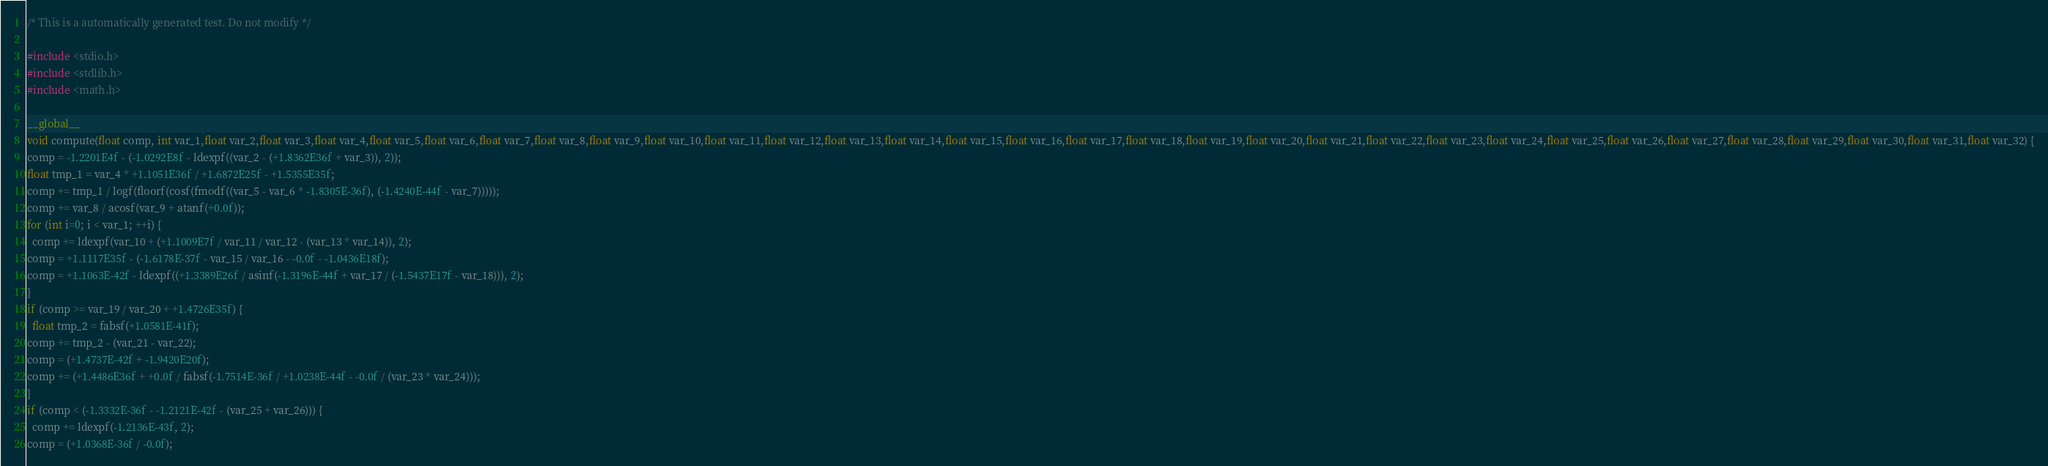<code> <loc_0><loc_0><loc_500><loc_500><_Cuda_>
/* This is a automatically generated test. Do not modify */

#include <stdio.h>
#include <stdlib.h>
#include <math.h>

__global__
void compute(float comp, int var_1,float var_2,float var_3,float var_4,float var_5,float var_6,float var_7,float var_8,float var_9,float var_10,float var_11,float var_12,float var_13,float var_14,float var_15,float var_16,float var_17,float var_18,float var_19,float var_20,float var_21,float var_22,float var_23,float var_24,float var_25,float var_26,float var_27,float var_28,float var_29,float var_30,float var_31,float var_32) {
comp = -1.2201E4f - (-1.0292E8f - ldexpf((var_2 - (+1.8362E36f + var_3)), 2));
float tmp_1 = var_4 * +1.1051E36f / +1.6872E25f - +1.5355E35f;
comp += tmp_1 / logf(floorf(cosf(fmodf((var_5 - var_6 * -1.8305E-36f), (-1.4240E-44f - var_7)))));
comp += var_8 / acosf(var_9 + atanf(+0.0f));
for (int i=0; i < var_1; ++i) {
  comp += ldexpf(var_10 + (+1.1009E7f / var_11 / var_12 - (var_13 * var_14)), 2);
comp = +1.1117E35f - (-1.6178E-37f - var_15 / var_16 - -0.0f - -1.0436E18f);
comp = +1.1063E-42f - ldexpf((+1.3389E26f / asinf(-1.3196E-44f + var_17 / (-1.5437E17f - var_18))), 2);
}
if (comp >= var_19 / var_20 + +1.4726E35f) {
  float tmp_2 = fabsf(+1.0581E-41f);
comp += tmp_2 - (var_21 - var_22);
comp = (+1.4737E-42f + -1.9420E20f);
comp += (+1.4486E36f + +0.0f / fabsf(-1.7514E-36f / +1.0238E-44f - -0.0f / (var_23 * var_24)));
}
if (comp < (-1.3332E-36f - -1.2121E-42f - (var_25 + var_26))) {
  comp += ldexpf(-1.2136E-43f, 2);
comp = (+1.0368E-36f / -0.0f);</code> 